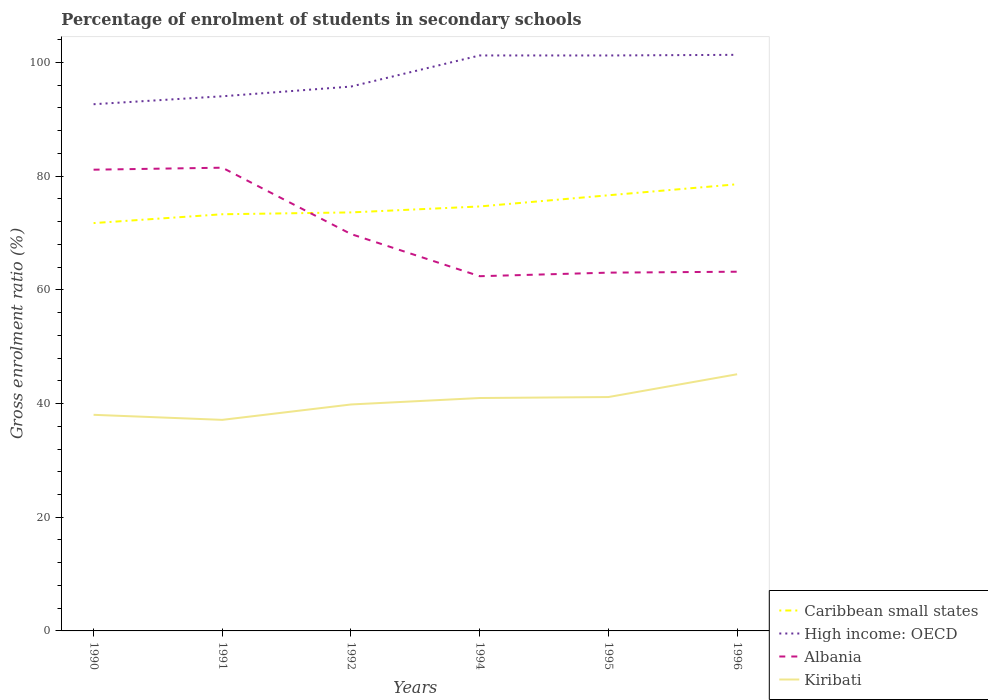How many different coloured lines are there?
Your answer should be very brief. 4. Across all years, what is the maximum percentage of students enrolled in secondary schools in Kiribati?
Provide a succinct answer. 37.13. What is the total percentage of students enrolled in secondary schools in Albania in the graph?
Provide a short and direct response. 18.3. What is the difference between the highest and the second highest percentage of students enrolled in secondary schools in Kiribati?
Offer a very short reply. 8.02. What is the difference between the highest and the lowest percentage of students enrolled in secondary schools in Caribbean small states?
Offer a terse response. 2. How many lines are there?
Make the answer very short. 4. How many years are there in the graph?
Provide a short and direct response. 6. What is the difference between two consecutive major ticks on the Y-axis?
Make the answer very short. 20. Are the values on the major ticks of Y-axis written in scientific E-notation?
Your answer should be compact. No. Where does the legend appear in the graph?
Offer a terse response. Bottom right. How are the legend labels stacked?
Make the answer very short. Vertical. What is the title of the graph?
Provide a succinct answer. Percentage of enrolment of students in secondary schools. What is the Gross enrolment ratio (%) of Caribbean small states in 1990?
Your answer should be compact. 71.75. What is the Gross enrolment ratio (%) of High income: OECD in 1990?
Keep it short and to the point. 92.65. What is the Gross enrolment ratio (%) in Albania in 1990?
Provide a short and direct response. 81.14. What is the Gross enrolment ratio (%) in Kiribati in 1990?
Make the answer very short. 38.02. What is the Gross enrolment ratio (%) in Caribbean small states in 1991?
Provide a short and direct response. 73.3. What is the Gross enrolment ratio (%) in High income: OECD in 1991?
Your answer should be compact. 94.05. What is the Gross enrolment ratio (%) in Albania in 1991?
Ensure brevity in your answer.  81.49. What is the Gross enrolment ratio (%) of Kiribati in 1991?
Provide a short and direct response. 37.13. What is the Gross enrolment ratio (%) in Caribbean small states in 1992?
Give a very brief answer. 73.62. What is the Gross enrolment ratio (%) of High income: OECD in 1992?
Your answer should be compact. 95.76. What is the Gross enrolment ratio (%) of Albania in 1992?
Provide a short and direct response. 69.82. What is the Gross enrolment ratio (%) of Kiribati in 1992?
Offer a very short reply. 39.84. What is the Gross enrolment ratio (%) in Caribbean small states in 1994?
Give a very brief answer. 74.67. What is the Gross enrolment ratio (%) in High income: OECD in 1994?
Your answer should be compact. 101.24. What is the Gross enrolment ratio (%) in Albania in 1994?
Offer a very short reply. 62.4. What is the Gross enrolment ratio (%) of Kiribati in 1994?
Give a very brief answer. 40.97. What is the Gross enrolment ratio (%) of Caribbean small states in 1995?
Your answer should be compact. 76.64. What is the Gross enrolment ratio (%) of High income: OECD in 1995?
Offer a terse response. 101.23. What is the Gross enrolment ratio (%) in Albania in 1995?
Make the answer very short. 63.03. What is the Gross enrolment ratio (%) in Kiribati in 1995?
Provide a short and direct response. 41.14. What is the Gross enrolment ratio (%) in Caribbean small states in 1996?
Provide a succinct answer. 78.58. What is the Gross enrolment ratio (%) of High income: OECD in 1996?
Your response must be concise. 101.34. What is the Gross enrolment ratio (%) in Albania in 1996?
Your answer should be very brief. 63.19. What is the Gross enrolment ratio (%) of Kiribati in 1996?
Offer a very short reply. 45.15. Across all years, what is the maximum Gross enrolment ratio (%) of Caribbean small states?
Your answer should be very brief. 78.58. Across all years, what is the maximum Gross enrolment ratio (%) in High income: OECD?
Give a very brief answer. 101.34. Across all years, what is the maximum Gross enrolment ratio (%) in Albania?
Offer a very short reply. 81.49. Across all years, what is the maximum Gross enrolment ratio (%) of Kiribati?
Your answer should be compact. 45.15. Across all years, what is the minimum Gross enrolment ratio (%) of Caribbean small states?
Provide a succinct answer. 71.75. Across all years, what is the minimum Gross enrolment ratio (%) in High income: OECD?
Make the answer very short. 92.65. Across all years, what is the minimum Gross enrolment ratio (%) of Albania?
Keep it short and to the point. 62.4. Across all years, what is the minimum Gross enrolment ratio (%) of Kiribati?
Your answer should be very brief. 37.13. What is the total Gross enrolment ratio (%) in Caribbean small states in the graph?
Your answer should be very brief. 448.55. What is the total Gross enrolment ratio (%) of High income: OECD in the graph?
Offer a very short reply. 586.28. What is the total Gross enrolment ratio (%) of Albania in the graph?
Provide a succinct answer. 421.06. What is the total Gross enrolment ratio (%) of Kiribati in the graph?
Give a very brief answer. 242.25. What is the difference between the Gross enrolment ratio (%) in Caribbean small states in 1990 and that in 1991?
Make the answer very short. -1.55. What is the difference between the Gross enrolment ratio (%) in High income: OECD in 1990 and that in 1991?
Offer a very short reply. -1.4. What is the difference between the Gross enrolment ratio (%) in Albania in 1990 and that in 1991?
Ensure brevity in your answer.  -0.35. What is the difference between the Gross enrolment ratio (%) in Kiribati in 1990 and that in 1991?
Your response must be concise. 0.89. What is the difference between the Gross enrolment ratio (%) in Caribbean small states in 1990 and that in 1992?
Provide a succinct answer. -1.88. What is the difference between the Gross enrolment ratio (%) of High income: OECD in 1990 and that in 1992?
Your answer should be very brief. -3.11. What is the difference between the Gross enrolment ratio (%) of Albania in 1990 and that in 1992?
Your answer should be compact. 11.32. What is the difference between the Gross enrolment ratio (%) in Kiribati in 1990 and that in 1992?
Offer a very short reply. -1.82. What is the difference between the Gross enrolment ratio (%) in Caribbean small states in 1990 and that in 1994?
Your answer should be compact. -2.92. What is the difference between the Gross enrolment ratio (%) of High income: OECD in 1990 and that in 1994?
Give a very brief answer. -8.58. What is the difference between the Gross enrolment ratio (%) of Albania in 1990 and that in 1994?
Provide a short and direct response. 18.74. What is the difference between the Gross enrolment ratio (%) in Kiribati in 1990 and that in 1994?
Give a very brief answer. -2.96. What is the difference between the Gross enrolment ratio (%) of Caribbean small states in 1990 and that in 1995?
Ensure brevity in your answer.  -4.89. What is the difference between the Gross enrolment ratio (%) in High income: OECD in 1990 and that in 1995?
Offer a very short reply. -8.58. What is the difference between the Gross enrolment ratio (%) in Albania in 1990 and that in 1995?
Your answer should be very brief. 18.11. What is the difference between the Gross enrolment ratio (%) in Kiribati in 1990 and that in 1995?
Provide a short and direct response. -3.13. What is the difference between the Gross enrolment ratio (%) of Caribbean small states in 1990 and that in 1996?
Keep it short and to the point. -6.83. What is the difference between the Gross enrolment ratio (%) of High income: OECD in 1990 and that in 1996?
Offer a terse response. -8.69. What is the difference between the Gross enrolment ratio (%) of Albania in 1990 and that in 1996?
Give a very brief answer. 17.95. What is the difference between the Gross enrolment ratio (%) in Kiribati in 1990 and that in 1996?
Provide a short and direct response. -7.14. What is the difference between the Gross enrolment ratio (%) of Caribbean small states in 1991 and that in 1992?
Ensure brevity in your answer.  -0.33. What is the difference between the Gross enrolment ratio (%) in High income: OECD in 1991 and that in 1992?
Your answer should be compact. -1.71. What is the difference between the Gross enrolment ratio (%) in Albania in 1991 and that in 1992?
Give a very brief answer. 11.67. What is the difference between the Gross enrolment ratio (%) of Kiribati in 1991 and that in 1992?
Provide a short and direct response. -2.71. What is the difference between the Gross enrolment ratio (%) in Caribbean small states in 1991 and that in 1994?
Provide a short and direct response. -1.37. What is the difference between the Gross enrolment ratio (%) of High income: OECD in 1991 and that in 1994?
Your response must be concise. -7.18. What is the difference between the Gross enrolment ratio (%) of Albania in 1991 and that in 1994?
Ensure brevity in your answer.  19.09. What is the difference between the Gross enrolment ratio (%) in Kiribati in 1991 and that in 1994?
Keep it short and to the point. -3.84. What is the difference between the Gross enrolment ratio (%) in Caribbean small states in 1991 and that in 1995?
Your response must be concise. -3.34. What is the difference between the Gross enrolment ratio (%) of High income: OECD in 1991 and that in 1995?
Your answer should be compact. -7.18. What is the difference between the Gross enrolment ratio (%) of Albania in 1991 and that in 1995?
Your answer should be very brief. 18.46. What is the difference between the Gross enrolment ratio (%) in Kiribati in 1991 and that in 1995?
Ensure brevity in your answer.  -4.01. What is the difference between the Gross enrolment ratio (%) in Caribbean small states in 1991 and that in 1996?
Provide a short and direct response. -5.28. What is the difference between the Gross enrolment ratio (%) of High income: OECD in 1991 and that in 1996?
Offer a terse response. -7.29. What is the difference between the Gross enrolment ratio (%) in Albania in 1991 and that in 1996?
Your answer should be very brief. 18.3. What is the difference between the Gross enrolment ratio (%) of Kiribati in 1991 and that in 1996?
Ensure brevity in your answer.  -8.02. What is the difference between the Gross enrolment ratio (%) of Caribbean small states in 1992 and that in 1994?
Your answer should be compact. -1.05. What is the difference between the Gross enrolment ratio (%) in High income: OECD in 1992 and that in 1994?
Give a very brief answer. -5.47. What is the difference between the Gross enrolment ratio (%) in Albania in 1992 and that in 1994?
Your answer should be compact. 7.42. What is the difference between the Gross enrolment ratio (%) of Kiribati in 1992 and that in 1994?
Make the answer very short. -1.14. What is the difference between the Gross enrolment ratio (%) in Caribbean small states in 1992 and that in 1995?
Your answer should be compact. -3.01. What is the difference between the Gross enrolment ratio (%) in High income: OECD in 1992 and that in 1995?
Keep it short and to the point. -5.47. What is the difference between the Gross enrolment ratio (%) in Albania in 1992 and that in 1995?
Ensure brevity in your answer.  6.79. What is the difference between the Gross enrolment ratio (%) in Kiribati in 1992 and that in 1995?
Your answer should be compact. -1.31. What is the difference between the Gross enrolment ratio (%) in Caribbean small states in 1992 and that in 1996?
Your response must be concise. -4.95. What is the difference between the Gross enrolment ratio (%) of High income: OECD in 1992 and that in 1996?
Keep it short and to the point. -5.58. What is the difference between the Gross enrolment ratio (%) of Albania in 1992 and that in 1996?
Provide a short and direct response. 6.63. What is the difference between the Gross enrolment ratio (%) in Kiribati in 1992 and that in 1996?
Give a very brief answer. -5.32. What is the difference between the Gross enrolment ratio (%) of Caribbean small states in 1994 and that in 1995?
Your answer should be very brief. -1.97. What is the difference between the Gross enrolment ratio (%) of High income: OECD in 1994 and that in 1995?
Offer a very short reply. 0. What is the difference between the Gross enrolment ratio (%) of Albania in 1994 and that in 1995?
Offer a terse response. -0.63. What is the difference between the Gross enrolment ratio (%) of Kiribati in 1994 and that in 1995?
Ensure brevity in your answer.  -0.17. What is the difference between the Gross enrolment ratio (%) in Caribbean small states in 1994 and that in 1996?
Ensure brevity in your answer.  -3.91. What is the difference between the Gross enrolment ratio (%) of High income: OECD in 1994 and that in 1996?
Make the answer very short. -0.11. What is the difference between the Gross enrolment ratio (%) of Albania in 1994 and that in 1996?
Offer a very short reply. -0.79. What is the difference between the Gross enrolment ratio (%) in Kiribati in 1994 and that in 1996?
Your response must be concise. -4.18. What is the difference between the Gross enrolment ratio (%) of Caribbean small states in 1995 and that in 1996?
Offer a terse response. -1.94. What is the difference between the Gross enrolment ratio (%) of High income: OECD in 1995 and that in 1996?
Ensure brevity in your answer.  -0.11. What is the difference between the Gross enrolment ratio (%) of Albania in 1995 and that in 1996?
Your response must be concise. -0.16. What is the difference between the Gross enrolment ratio (%) of Kiribati in 1995 and that in 1996?
Your answer should be compact. -4.01. What is the difference between the Gross enrolment ratio (%) in Caribbean small states in 1990 and the Gross enrolment ratio (%) in High income: OECD in 1991?
Provide a short and direct response. -22.31. What is the difference between the Gross enrolment ratio (%) of Caribbean small states in 1990 and the Gross enrolment ratio (%) of Albania in 1991?
Make the answer very short. -9.75. What is the difference between the Gross enrolment ratio (%) in Caribbean small states in 1990 and the Gross enrolment ratio (%) in Kiribati in 1991?
Offer a very short reply. 34.62. What is the difference between the Gross enrolment ratio (%) in High income: OECD in 1990 and the Gross enrolment ratio (%) in Albania in 1991?
Your response must be concise. 11.16. What is the difference between the Gross enrolment ratio (%) of High income: OECD in 1990 and the Gross enrolment ratio (%) of Kiribati in 1991?
Your answer should be compact. 55.53. What is the difference between the Gross enrolment ratio (%) in Albania in 1990 and the Gross enrolment ratio (%) in Kiribati in 1991?
Offer a very short reply. 44.01. What is the difference between the Gross enrolment ratio (%) in Caribbean small states in 1990 and the Gross enrolment ratio (%) in High income: OECD in 1992?
Ensure brevity in your answer.  -24.02. What is the difference between the Gross enrolment ratio (%) in Caribbean small states in 1990 and the Gross enrolment ratio (%) in Albania in 1992?
Your answer should be very brief. 1.93. What is the difference between the Gross enrolment ratio (%) of Caribbean small states in 1990 and the Gross enrolment ratio (%) of Kiribati in 1992?
Provide a short and direct response. 31.91. What is the difference between the Gross enrolment ratio (%) in High income: OECD in 1990 and the Gross enrolment ratio (%) in Albania in 1992?
Give a very brief answer. 22.84. What is the difference between the Gross enrolment ratio (%) in High income: OECD in 1990 and the Gross enrolment ratio (%) in Kiribati in 1992?
Make the answer very short. 52.82. What is the difference between the Gross enrolment ratio (%) of Albania in 1990 and the Gross enrolment ratio (%) of Kiribati in 1992?
Your response must be concise. 41.3. What is the difference between the Gross enrolment ratio (%) of Caribbean small states in 1990 and the Gross enrolment ratio (%) of High income: OECD in 1994?
Ensure brevity in your answer.  -29.49. What is the difference between the Gross enrolment ratio (%) of Caribbean small states in 1990 and the Gross enrolment ratio (%) of Albania in 1994?
Your answer should be very brief. 9.34. What is the difference between the Gross enrolment ratio (%) in Caribbean small states in 1990 and the Gross enrolment ratio (%) in Kiribati in 1994?
Keep it short and to the point. 30.77. What is the difference between the Gross enrolment ratio (%) of High income: OECD in 1990 and the Gross enrolment ratio (%) of Albania in 1994?
Your answer should be compact. 30.25. What is the difference between the Gross enrolment ratio (%) of High income: OECD in 1990 and the Gross enrolment ratio (%) of Kiribati in 1994?
Provide a succinct answer. 51.68. What is the difference between the Gross enrolment ratio (%) of Albania in 1990 and the Gross enrolment ratio (%) of Kiribati in 1994?
Give a very brief answer. 40.17. What is the difference between the Gross enrolment ratio (%) in Caribbean small states in 1990 and the Gross enrolment ratio (%) in High income: OECD in 1995?
Your answer should be very brief. -29.49. What is the difference between the Gross enrolment ratio (%) in Caribbean small states in 1990 and the Gross enrolment ratio (%) in Albania in 1995?
Keep it short and to the point. 8.72. What is the difference between the Gross enrolment ratio (%) of Caribbean small states in 1990 and the Gross enrolment ratio (%) of Kiribati in 1995?
Keep it short and to the point. 30.6. What is the difference between the Gross enrolment ratio (%) in High income: OECD in 1990 and the Gross enrolment ratio (%) in Albania in 1995?
Provide a succinct answer. 29.63. What is the difference between the Gross enrolment ratio (%) in High income: OECD in 1990 and the Gross enrolment ratio (%) in Kiribati in 1995?
Your answer should be very brief. 51.51. What is the difference between the Gross enrolment ratio (%) of Albania in 1990 and the Gross enrolment ratio (%) of Kiribati in 1995?
Offer a terse response. 40. What is the difference between the Gross enrolment ratio (%) of Caribbean small states in 1990 and the Gross enrolment ratio (%) of High income: OECD in 1996?
Make the answer very short. -29.6. What is the difference between the Gross enrolment ratio (%) in Caribbean small states in 1990 and the Gross enrolment ratio (%) in Albania in 1996?
Provide a short and direct response. 8.55. What is the difference between the Gross enrolment ratio (%) of Caribbean small states in 1990 and the Gross enrolment ratio (%) of Kiribati in 1996?
Keep it short and to the point. 26.59. What is the difference between the Gross enrolment ratio (%) of High income: OECD in 1990 and the Gross enrolment ratio (%) of Albania in 1996?
Give a very brief answer. 29.46. What is the difference between the Gross enrolment ratio (%) of High income: OECD in 1990 and the Gross enrolment ratio (%) of Kiribati in 1996?
Provide a short and direct response. 47.5. What is the difference between the Gross enrolment ratio (%) of Albania in 1990 and the Gross enrolment ratio (%) of Kiribati in 1996?
Your answer should be very brief. 35.99. What is the difference between the Gross enrolment ratio (%) in Caribbean small states in 1991 and the Gross enrolment ratio (%) in High income: OECD in 1992?
Provide a short and direct response. -22.47. What is the difference between the Gross enrolment ratio (%) of Caribbean small states in 1991 and the Gross enrolment ratio (%) of Albania in 1992?
Your response must be concise. 3.48. What is the difference between the Gross enrolment ratio (%) in Caribbean small states in 1991 and the Gross enrolment ratio (%) in Kiribati in 1992?
Keep it short and to the point. 33.46. What is the difference between the Gross enrolment ratio (%) of High income: OECD in 1991 and the Gross enrolment ratio (%) of Albania in 1992?
Keep it short and to the point. 24.23. What is the difference between the Gross enrolment ratio (%) in High income: OECD in 1991 and the Gross enrolment ratio (%) in Kiribati in 1992?
Your answer should be compact. 54.22. What is the difference between the Gross enrolment ratio (%) of Albania in 1991 and the Gross enrolment ratio (%) of Kiribati in 1992?
Your answer should be very brief. 41.65. What is the difference between the Gross enrolment ratio (%) of Caribbean small states in 1991 and the Gross enrolment ratio (%) of High income: OECD in 1994?
Provide a short and direct response. -27.94. What is the difference between the Gross enrolment ratio (%) of Caribbean small states in 1991 and the Gross enrolment ratio (%) of Albania in 1994?
Your answer should be compact. 10.9. What is the difference between the Gross enrolment ratio (%) in Caribbean small states in 1991 and the Gross enrolment ratio (%) in Kiribati in 1994?
Your response must be concise. 32.33. What is the difference between the Gross enrolment ratio (%) in High income: OECD in 1991 and the Gross enrolment ratio (%) in Albania in 1994?
Offer a terse response. 31.65. What is the difference between the Gross enrolment ratio (%) in High income: OECD in 1991 and the Gross enrolment ratio (%) in Kiribati in 1994?
Your answer should be very brief. 53.08. What is the difference between the Gross enrolment ratio (%) of Albania in 1991 and the Gross enrolment ratio (%) of Kiribati in 1994?
Make the answer very short. 40.52. What is the difference between the Gross enrolment ratio (%) in Caribbean small states in 1991 and the Gross enrolment ratio (%) in High income: OECD in 1995?
Ensure brevity in your answer.  -27.93. What is the difference between the Gross enrolment ratio (%) of Caribbean small states in 1991 and the Gross enrolment ratio (%) of Albania in 1995?
Keep it short and to the point. 10.27. What is the difference between the Gross enrolment ratio (%) in Caribbean small states in 1991 and the Gross enrolment ratio (%) in Kiribati in 1995?
Provide a short and direct response. 32.16. What is the difference between the Gross enrolment ratio (%) of High income: OECD in 1991 and the Gross enrolment ratio (%) of Albania in 1995?
Offer a terse response. 31.02. What is the difference between the Gross enrolment ratio (%) of High income: OECD in 1991 and the Gross enrolment ratio (%) of Kiribati in 1995?
Your answer should be very brief. 52.91. What is the difference between the Gross enrolment ratio (%) in Albania in 1991 and the Gross enrolment ratio (%) in Kiribati in 1995?
Keep it short and to the point. 40.35. What is the difference between the Gross enrolment ratio (%) in Caribbean small states in 1991 and the Gross enrolment ratio (%) in High income: OECD in 1996?
Offer a very short reply. -28.05. What is the difference between the Gross enrolment ratio (%) in Caribbean small states in 1991 and the Gross enrolment ratio (%) in Albania in 1996?
Ensure brevity in your answer.  10.11. What is the difference between the Gross enrolment ratio (%) of Caribbean small states in 1991 and the Gross enrolment ratio (%) of Kiribati in 1996?
Ensure brevity in your answer.  28.15. What is the difference between the Gross enrolment ratio (%) of High income: OECD in 1991 and the Gross enrolment ratio (%) of Albania in 1996?
Your response must be concise. 30.86. What is the difference between the Gross enrolment ratio (%) of High income: OECD in 1991 and the Gross enrolment ratio (%) of Kiribati in 1996?
Provide a succinct answer. 48.9. What is the difference between the Gross enrolment ratio (%) of Albania in 1991 and the Gross enrolment ratio (%) of Kiribati in 1996?
Make the answer very short. 36.34. What is the difference between the Gross enrolment ratio (%) in Caribbean small states in 1992 and the Gross enrolment ratio (%) in High income: OECD in 1994?
Provide a short and direct response. -27.61. What is the difference between the Gross enrolment ratio (%) in Caribbean small states in 1992 and the Gross enrolment ratio (%) in Albania in 1994?
Your response must be concise. 11.22. What is the difference between the Gross enrolment ratio (%) in Caribbean small states in 1992 and the Gross enrolment ratio (%) in Kiribati in 1994?
Your answer should be compact. 32.65. What is the difference between the Gross enrolment ratio (%) in High income: OECD in 1992 and the Gross enrolment ratio (%) in Albania in 1994?
Offer a very short reply. 33.36. What is the difference between the Gross enrolment ratio (%) of High income: OECD in 1992 and the Gross enrolment ratio (%) of Kiribati in 1994?
Provide a short and direct response. 54.79. What is the difference between the Gross enrolment ratio (%) in Albania in 1992 and the Gross enrolment ratio (%) in Kiribati in 1994?
Provide a succinct answer. 28.84. What is the difference between the Gross enrolment ratio (%) in Caribbean small states in 1992 and the Gross enrolment ratio (%) in High income: OECD in 1995?
Provide a succinct answer. -27.61. What is the difference between the Gross enrolment ratio (%) in Caribbean small states in 1992 and the Gross enrolment ratio (%) in Albania in 1995?
Provide a succinct answer. 10.6. What is the difference between the Gross enrolment ratio (%) in Caribbean small states in 1992 and the Gross enrolment ratio (%) in Kiribati in 1995?
Make the answer very short. 32.48. What is the difference between the Gross enrolment ratio (%) of High income: OECD in 1992 and the Gross enrolment ratio (%) of Albania in 1995?
Offer a terse response. 32.74. What is the difference between the Gross enrolment ratio (%) of High income: OECD in 1992 and the Gross enrolment ratio (%) of Kiribati in 1995?
Your answer should be compact. 54.62. What is the difference between the Gross enrolment ratio (%) in Albania in 1992 and the Gross enrolment ratio (%) in Kiribati in 1995?
Offer a very short reply. 28.67. What is the difference between the Gross enrolment ratio (%) of Caribbean small states in 1992 and the Gross enrolment ratio (%) of High income: OECD in 1996?
Your answer should be very brief. -27.72. What is the difference between the Gross enrolment ratio (%) in Caribbean small states in 1992 and the Gross enrolment ratio (%) in Albania in 1996?
Offer a very short reply. 10.43. What is the difference between the Gross enrolment ratio (%) of Caribbean small states in 1992 and the Gross enrolment ratio (%) of Kiribati in 1996?
Your answer should be very brief. 28.47. What is the difference between the Gross enrolment ratio (%) of High income: OECD in 1992 and the Gross enrolment ratio (%) of Albania in 1996?
Offer a terse response. 32.57. What is the difference between the Gross enrolment ratio (%) of High income: OECD in 1992 and the Gross enrolment ratio (%) of Kiribati in 1996?
Give a very brief answer. 50.61. What is the difference between the Gross enrolment ratio (%) of Albania in 1992 and the Gross enrolment ratio (%) of Kiribati in 1996?
Your answer should be compact. 24.66. What is the difference between the Gross enrolment ratio (%) of Caribbean small states in 1994 and the Gross enrolment ratio (%) of High income: OECD in 1995?
Your answer should be very brief. -26.56. What is the difference between the Gross enrolment ratio (%) of Caribbean small states in 1994 and the Gross enrolment ratio (%) of Albania in 1995?
Provide a succinct answer. 11.64. What is the difference between the Gross enrolment ratio (%) of Caribbean small states in 1994 and the Gross enrolment ratio (%) of Kiribati in 1995?
Provide a short and direct response. 33.53. What is the difference between the Gross enrolment ratio (%) of High income: OECD in 1994 and the Gross enrolment ratio (%) of Albania in 1995?
Your answer should be very brief. 38.21. What is the difference between the Gross enrolment ratio (%) in High income: OECD in 1994 and the Gross enrolment ratio (%) in Kiribati in 1995?
Your answer should be compact. 60.09. What is the difference between the Gross enrolment ratio (%) in Albania in 1994 and the Gross enrolment ratio (%) in Kiribati in 1995?
Your response must be concise. 21.26. What is the difference between the Gross enrolment ratio (%) in Caribbean small states in 1994 and the Gross enrolment ratio (%) in High income: OECD in 1996?
Keep it short and to the point. -26.67. What is the difference between the Gross enrolment ratio (%) in Caribbean small states in 1994 and the Gross enrolment ratio (%) in Albania in 1996?
Offer a very short reply. 11.48. What is the difference between the Gross enrolment ratio (%) of Caribbean small states in 1994 and the Gross enrolment ratio (%) of Kiribati in 1996?
Provide a short and direct response. 29.52. What is the difference between the Gross enrolment ratio (%) in High income: OECD in 1994 and the Gross enrolment ratio (%) in Albania in 1996?
Offer a very short reply. 38.04. What is the difference between the Gross enrolment ratio (%) in High income: OECD in 1994 and the Gross enrolment ratio (%) in Kiribati in 1996?
Make the answer very short. 56.08. What is the difference between the Gross enrolment ratio (%) of Albania in 1994 and the Gross enrolment ratio (%) of Kiribati in 1996?
Make the answer very short. 17.25. What is the difference between the Gross enrolment ratio (%) of Caribbean small states in 1995 and the Gross enrolment ratio (%) of High income: OECD in 1996?
Your response must be concise. -24.71. What is the difference between the Gross enrolment ratio (%) in Caribbean small states in 1995 and the Gross enrolment ratio (%) in Albania in 1996?
Give a very brief answer. 13.45. What is the difference between the Gross enrolment ratio (%) of Caribbean small states in 1995 and the Gross enrolment ratio (%) of Kiribati in 1996?
Offer a terse response. 31.48. What is the difference between the Gross enrolment ratio (%) of High income: OECD in 1995 and the Gross enrolment ratio (%) of Albania in 1996?
Ensure brevity in your answer.  38.04. What is the difference between the Gross enrolment ratio (%) in High income: OECD in 1995 and the Gross enrolment ratio (%) in Kiribati in 1996?
Your response must be concise. 56.08. What is the difference between the Gross enrolment ratio (%) in Albania in 1995 and the Gross enrolment ratio (%) in Kiribati in 1996?
Give a very brief answer. 17.87. What is the average Gross enrolment ratio (%) in Caribbean small states per year?
Your response must be concise. 74.76. What is the average Gross enrolment ratio (%) in High income: OECD per year?
Your answer should be very brief. 97.71. What is the average Gross enrolment ratio (%) in Albania per year?
Your answer should be compact. 70.18. What is the average Gross enrolment ratio (%) in Kiribati per year?
Ensure brevity in your answer.  40.38. In the year 1990, what is the difference between the Gross enrolment ratio (%) in Caribbean small states and Gross enrolment ratio (%) in High income: OECD?
Make the answer very short. -20.91. In the year 1990, what is the difference between the Gross enrolment ratio (%) of Caribbean small states and Gross enrolment ratio (%) of Albania?
Your answer should be compact. -9.39. In the year 1990, what is the difference between the Gross enrolment ratio (%) in Caribbean small states and Gross enrolment ratio (%) in Kiribati?
Provide a succinct answer. 33.73. In the year 1990, what is the difference between the Gross enrolment ratio (%) of High income: OECD and Gross enrolment ratio (%) of Albania?
Offer a very short reply. 11.52. In the year 1990, what is the difference between the Gross enrolment ratio (%) in High income: OECD and Gross enrolment ratio (%) in Kiribati?
Your answer should be very brief. 54.64. In the year 1990, what is the difference between the Gross enrolment ratio (%) in Albania and Gross enrolment ratio (%) in Kiribati?
Your answer should be compact. 43.12. In the year 1991, what is the difference between the Gross enrolment ratio (%) of Caribbean small states and Gross enrolment ratio (%) of High income: OECD?
Your answer should be compact. -20.75. In the year 1991, what is the difference between the Gross enrolment ratio (%) of Caribbean small states and Gross enrolment ratio (%) of Albania?
Give a very brief answer. -8.19. In the year 1991, what is the difference between the Gross enrolment ratio (%) in Caribbean small states and Gross enrolment ratio (%) in Kiribati?
Provide a short and direct response. 36.17. In the year 1991, what is the difference between the Gross enrolment ratio (%) in High income: OECD and Gross enrolment ratio (%) in Albania?
Your response must be concise. 12.56. In the year 1991, what is the difference between the Gross enrolment ratio (%) of High income: OECD and Gross enrolment ratio (%) of Kiribati?
Provide a succinct answer. 56.92. In the year 1991, what is the difference between the Gross enrolment ratio (%) of Albania and Gross enrolment ratio (%) of Kiribati?
Offer a terse response. 44.36. In the year 1992, what is the difference between the Gross enrolment ratio (%) of Caribbean small states and Gross enrolment ratio (%) of High income: OECD?
Offer a very short reply. -22.14. In the year 1992, what is the difference between the Gross enrolment ratio (%) of Caribbean small states and Gross enrolment ratio (%) of Albania?
Your answer should be very brief. 3.81. In the year 1992, what is the difference between the Gross enrolment ratio (%) of Caribbean small states and Gross enrolment ratio (%) of Kiribati?
Give a very brief answer. 33.79. In the year 1992, what is the difference between the Gross enrolment ratio (%) in High income: OECD and Gross enrolment ratio (%) in Albania?
Make the answer very short. 25.95. In the year 1992, what is the difference between the Gross enrolment ratio (%) of High income: OECD and Gross enrolment ratio (%) of Kiribati?
Ensure brevity in your answer.  55.93. In the year 1992, what is the difference between the Gross enrolment ratio (%) in Albania and Gross enrolment ratio (%) in Kiribati?
Provide a succinct answer. 29.98. In the year 1994, what is the difference between the Gross enrolment ratio (%) in Caribbean small states and Gross enrolment ratio (%) in High income: OECD?
Make the answer very short. -26.57. In the year 1994, what is the difference between the Gross enrolment ratio (%) of Caribbean small states and Gross enrolment ratio (%) of Albania?
Your answer should be compact. 12.27. In the year 1994, what is the difference between the Gross enrolment ratio (%) of Caribbean small states and Gross enrolment ratio (%) of Kiribati?
Ensure brevity in your answer.  33.7. In the year 1994, what is the difference between the Gross enrolment ratio (%) of High income: OECD and Gross enrolment ratio (%) of Albania?
Provide a succinct answer. 38.84. In the year 1994, what is the difference between the Gross enrolment ratio (%) in High income: OECD and Gross enrolment ratio (%) in Kiribati?
Your answer should be very brief. 60.26. In the year 1994, what is the difference between the Gross enrolment ratio (%) of Albania and Gross enrolment ratio (%) of Kiribati?
Make the answer very short. 21.43. In the year 1995, what is the difference between the Gross enrolment ratio (%) of Caribbean small states and Gross enrolment ratio (%) of High income: OECD?
Make the answer very short. -24.6. In the year 1995, what is the difference between the Gross enrolment ratio (%) of Caribbean small states and Gross enrolment ratio (%) of Albania?
Give a very brief answer. 13.61. In the year 1995, what is the difference between the Gross enrolment ratio (%) in Caribbean small states and Gross enrolment ratio (%) in Kiribati?
Ensure brevity in your answer.  35.49. In the year 1995, what is the difference between the Gross enrolment ratio (%) of High income: OECD and Gross enrolment ratio (%) of Albania?
Make the answer very short. 38.2. In the year 1995, what is the difference between the Gross enrolment ratio (%) of High income: OECD and Gross enrolment ratio (%) of Kiribati?
Provide a succinct answer. 60.09. In the year 1995, what is the difference between the Gross enrolment ratio (%) in Albania and Gross enrolment ratio (%) in Kiribati?
Provide a succinct answer. 21.88. In the year 1996, what is the difference between the Gross enrolment ratio (%) of Caribbean small states and Gross enrolment ratio (%) of High income: OECD?
Provide a short and direct response. -22.77. In the year 1996, what is the difference between the Gross enrolment ratio (%) of Caribbean small states and Gross enrolment ratio (%) of Albania?
Your answer should be compact. 15.38. In the year 1996, what is the difference between the Gross enrolment ratio (%) in Caribbean small states and Gross enrolment ratio (%) in Kiribati?
Your answer should be very brief. 33.42. In the year 1996, what is the difference between the Gross enrolment ratio (%) in High income: OECD and Gross enrolment ratio (%) in Albania?
Ensure brevity in your answer.  38.15. In the year 1996, what is the difference between the Gross enrolment ratio (%) of High income: OECD and Gross enrolment ratio (%) of Kiribati?
Ensure brevity in your answer.  56.19. In the year 1996, what is the difference between the Gross enrolment ratio (%) in Albania and Gross enrolment ratio (%) in Kiribati?
Offer a terse response. 18.04. What is the ratio of the Gross enrolment ratio (%) in Caribbean small states in 1990 to that in 1991?
Ensure brevity in your answer.  0.98. What is the ratio of the Gross enrolment ratio (%) in High income: OECD in 1990 to that in 1991?
Keep it short and to the point. 0.99. What is the ratio of the Gross enrolment ratio (%) of Albania in 1990 to that in 1991?
Offer a terse response. 1. What is the ratio of the Gross enrolment ratio (%) in Kiribati in 1990 to that in 1991?
Provide a short and direct response. 1.02. What is the ratio of the Gross enrolment ratio (%) of Caribbean small states in 1990 to that in 1992?
Offer a terse response. 0.97. What is the ratio of the Gross enrolment ratio (%) in High income: OECD in 1990 to that in 1992?
Give a very brief answer. 0.97. What is the ratio of the Gross enrolment ratio (%) in Albania in 1990 to that in 1992?
Offer a very short reply. 1.16. What is the ratio of the Gross enrolment ratio (%) in Kiribati in 1990 to that in 1992?
Ensure brevity in your answer.  0.95. What is the ratio of the Gross enrolment ratio (%) of Caribbean small states in 1990 to that in 1994?
Give a very brief answer. 0.96. What is the ratio of the Gross enrolment ratio (%) in High income: OECD in 1990 to that in 1994?
Your answer should be compact. 0.92. What is the ratio of the Gross enrolment ratio (%) in Albania in 1990 to that in 1994?
Your answer should be very brief. 1.3. What is the ratio of the Gross enrolment ratio (%) of Kiribati in 1990 to that in 1994?
Provide a succinct answer. 0.93. What is the ratio of the Gross enrolment ratio (%) in Caribbean small states in 1990 to that in 1995?
Provide a short and direct response. 0.94. What is the ratio of the Gross enrolment ratio (%) in High income: OECD in 1990 to that in 1995?
Make the answer very short. 0.92. What is the ratio of the Gross enrolment ratio (%) in Albania in 1990 to that in 1995?
Your answer should be very brief. 1.29. What is the ratio of the Gross enrolment ratio (%) of Kiribati in 1990 to that in 1995?
Offer a very short reply. 0.92. What is the ratio of the Gross enrolment ratio (%) of Caribbean small states in 1990 to that in 1996?
Make the answer very short. 0.91. What is the ratio of the Gross enrolment ratio (%) of High income: OECD in 1990 to that in 1996?
Offer a very short reply. 0.91. What is the ratio of the Gross enrolment ratio (%) of Albania in 1990 to that in 1996?
Your answer should be compact. 1.28. What is the ratio of the Gross enrolment ratio (%) of Kiribati in 1990 to that in 1996?
Provide a short and direct response. 0.84. What is the ratio of the Gross enrolment ratio (%) of Caribbean small states in 1991 to that in 1992?
Give a very brief answer. 1. What is the ratio of the Gross enrolment ratio (%) of High income: OECD in 1991 to that in 1992?
Keep it short and to the point. 0.98. What is the ratio of the Gross enrolment ratio (%) of Albania in 1991 to that in 1992?
Offer a very short reply. 1.17. What is the ratio of the Gross enrolment ratio (%) in Kiribati in 1991 to that in 1992?
Make the answer very short. 0.93. What is the ratio of the Gross enrolment ratio (%) in Caribbean small states in 1991 to that in 1994?
Keep it short and to the point. 0.98. What is the ratio of the Gross enrolment ratio (%) of High income: OECD in 1991 to that in 1994?
Provide a short and direct response. 0.93. What is the ratio of the Gross enrolment ratio (%) of Albania in 1991 to that in 1994?
Provide a short and direct response. 1.31. What is the ratio of the Gross enrolment ratio (%) in Kiribati in 1991 to that in 1994?
Provide a succinct answer. 0.91. What is the ratio of the Gross enrolment ratio (%) of Caribbean small states in 1991 to that in 1995?
Provide a short and direct response. 0.96. What is the ratio of the Gross enrolment ratio (%) of High income: OECD in 1991 to that in 1995?
Your response must be concise. 0.93. What is the ratio of the Gross enrolment ratio (%) in Albania in 1991 to that in 1995?
Give a very brief answer. 1.29. What is the ratio of the Gross enrolment ratio (%) in Kiribati in 1991 to that in 1995?
Give a very brief answer. 0.9. What is the ratio of the Gross enrolment ratio (%) in Caribbean small states in 1991 to that in 1996?
Ensure brevity in your answer.  0.93. What is the ratio of the Gross enrolment ratio (%) in High income: OECD in 1991 to that in 1996?
Keep it short and to the point. 0.93. What is the ratio of the Gross enrolment ratio (%) in Albania in 1991 to that in 1996?
Keep it short and to the point. 1.29. What is the ratio of the Gross enrolment ratio (%) in Kiribati in 1991 to that in 1996?
Make the answer very short. 0.82. What is the ratio of the Gross enrolment ratio (%) of High income: OECD in 1992 to that in 1994?
Ensure brevity in your answer.  0.95. What is the ratio of the Gross enrolment ratio (%) in Albania in 1992 to that in 1994?
Make the answer very short. 1.12. What is the ratio of the Gross enrolment ratio (%) in Kiribati in 1992 to that in 1994?
Keep it short and to the point. 0.97. What is the ratio of the Gross enrolment ratio (%) of Caribbean small states in 1992 to that in 1995?
Give a very brief answer. 0.96. What is the ratio of the Gross enrolment ratio (%) in High income: OECD in 1992 to that in 1995?
Your answer should be very brief. 0.95. What is the ratio of the Gross enrolment ratio (%) in Albania in 1992 to that in 1995?
Offer a very short reply. 1.11. What is the ratio of the Gross enrolment ratio (%) in Kiribati in 1992 to that in 1995?
Give a very brief answer. 0.97. What is the ratio of the Gross enrolment ratio (%) in Caribbean small states in 1992 to that in 1996?
Provide a short and direct response. 0.94. What is the ratio of the Gross enrolment ratio (%) of High income: OECD in 1992 to that in 1996?
Your answer should be very brief. 0.94. What is the ratio of the Gross enrolment ratio (%) of Albania in 1992 to that in 1996?
Offer a terse response. 1.1. What is the ratio of the Gross enrolment ratio (%) of Kiribati in 1992 to that in 1996?
Provide a succinct answer. 0.88. What is the ratio of the Gross enrolment ratio (%) in Caribbean small states in 1994 to that in 1995?
Your answer should be very brief. 0.97. What is the ratio of the Gross enrolment ratio (%) of High income: OECD in 1994 to that in 1995?
Your response must be concise. 1. What is the ratio of the Gross enrolment ratio (%) in Albania in 1994 to that in 1995?
Offer a terse response. 0.99. What is the ratio of the Gross enrolment ratio (%) of Caribbean small states in 1994 to that in 1996?
Your answer should be very brief. 0.95. What is the ratio of the Gross enrolment ratio (%) in Albania in 1994 to that in 1996?
Your response must be concise. 0.99. What is the ratio of the Gross enrolment ratio (%) of Kiribati in 1994 to that in 1996?
Give a very brief answer. 0.91. What is the ratio of the Gross enrolment ratio (%) in Caribbean small states in 1995 to that in 1996?
Your answer should be compact. 0.98. What is the ratio of the Gross enrolment ratio (%) of Albania in 1995 to that in 1996?
Ensure brevity in your answer.  1. What is the ratio of the Gross enrolment ratio (%) of Kiribati in 1995 to that in 1996?
Ensure brevity in your answer.  0.91. What is the difference between the highest and the second highest Gross enrolment ratio (%) in Caribbean small states?
Ensure brevity in your answer.  1.94. What is the difference between the highest and the second highest Gross enrolment ratio (%) in High income: OECD?
Ensure brevity in your answer.  0.11. What is the difference between the highest and the second highest Gross enrolment ratio (%) in Albania?
Your answer should be very brief. 0.35. What is the difference between the highest and the second highest Gross enrolment ratio (%) in Kiribati?
Ensure brevity in your answer.  4.01. What is the difference between the highest and the lowest Gross enrolment ratio (%) of Caribbean small states?
Your answer should be compact. 6.83. What is the difference between the highest and the lowest Gross enrolment ratio (%) in High income: OECD?
Provide a short and direct response. 8.69. What is the difference between the highest and the lowest Gross enrolment ratio (%) of Albania?
Offer a terse response. 19.09. What is the difference between the highest and the lowest Gross enrolment ratio (%) in Kiribati?
Provide a succinct answer. 8.02. 